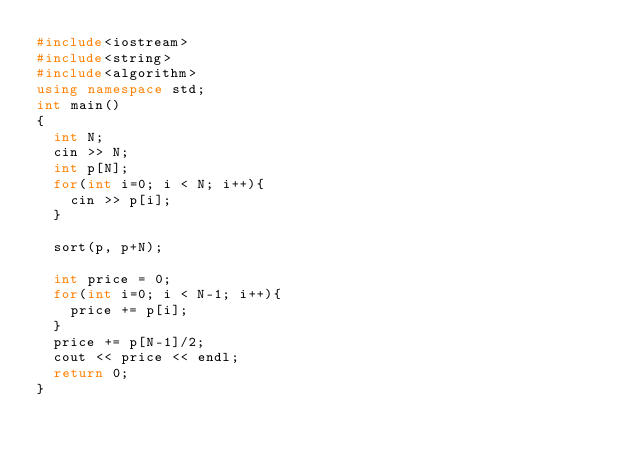<code> <loc_0><loc_0><loc_500><loc_500><_C++_>#include<iostream>
#include<string>
#include<algorithm>
using namespace std;
int main()
{
  int N;
  cin >> N;
  int p[N];
  for(int i=0; i < N; i++){
    cin >> p[i];
  }

  sort(p, p+N);

  int price = 0;
  for(int i=0; i < N-1; i++){
    price += p[i];
  }
  price += p[N-1]/2;
  cout << price << endl;
  return 0;
}
</code> 